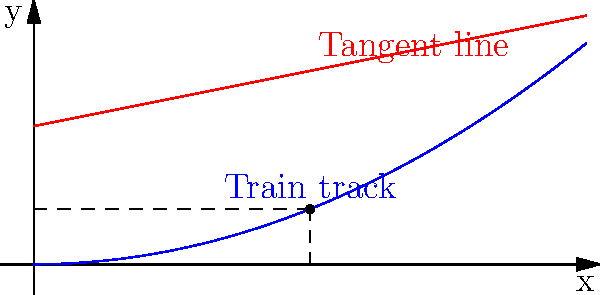A model train is climbing a steep gradient represented by the function $y = 0.1x^2$. At the point where $x = 2$, calculate the angle of inclination (in degrees) between the track and the horizontal. Use the derivative to find the slope of the tangent line at this point, and then apply trigonometric functions to determine the angle. Let's approach this step-by-step:

1) First, we need to find the derivative of the function $y = 0.1x^2$:
   $\frac{dy}{dx} = 0.2x$

2) At $x = 2$, the slope of the tangent line is:
   $\frac{dy}{dx}|_{x=2} = 0.2(2) = 0.4$

3) The slope of the tangent line represents the rate of change in y with respect to x, which is equal to the tangent of the angle of inclination:
   $\tan(\theta) = 0.4$

4) To find the angle $\theta$, we need to use the inverse tangent (arctangent) function:
   $\theta = \arctan(0.4)$

5) Convert this angle from radians to degrees:
   $\theta = \arctan(0.4) \cdot \frac{180°}{\pi}$

6) Calculating this:
   $\theta \approx 21.80°$

Therefore, the angle of inclination at $x = 2$ is approximately 21.80 degrees.
Answer: 21.80° 